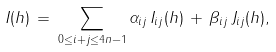Convert formula to latex. <formula><loc_0><loc_0><loc_500><loc_500>I ( h ) \, = \, \sum _ { 0 \leq i + j \leq 4 n - 1 } \alpha _ { i j } \, I _ { i j } ( h ) \, + \, \beta _ { i j } \, J _ { i j } ( h ) ,</formula> 